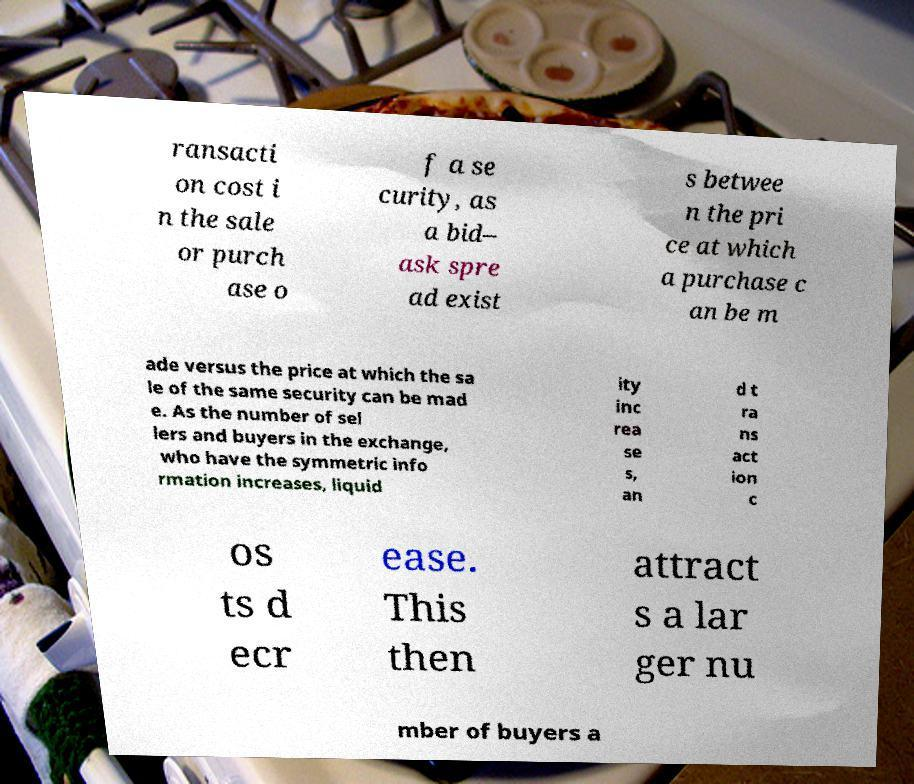There's text embedded in this image that I need extracted. Can you transcribe it verbatim? ransacti on cost i n the sale or purch ase o f a se curity, as a bid– ask spre ad exist s betwee n the pri ce at which a purchase c an be m ade versus the price at which the sa le of the same security can be mad e. As the number of sel lers and buyers in the exchange, who have the symmetric info rmation increases, liquid ity inc rea se s, an d t ra ns act ion c os ts d ecr ease. This then attract s a lar ger nu mber of buyers a 